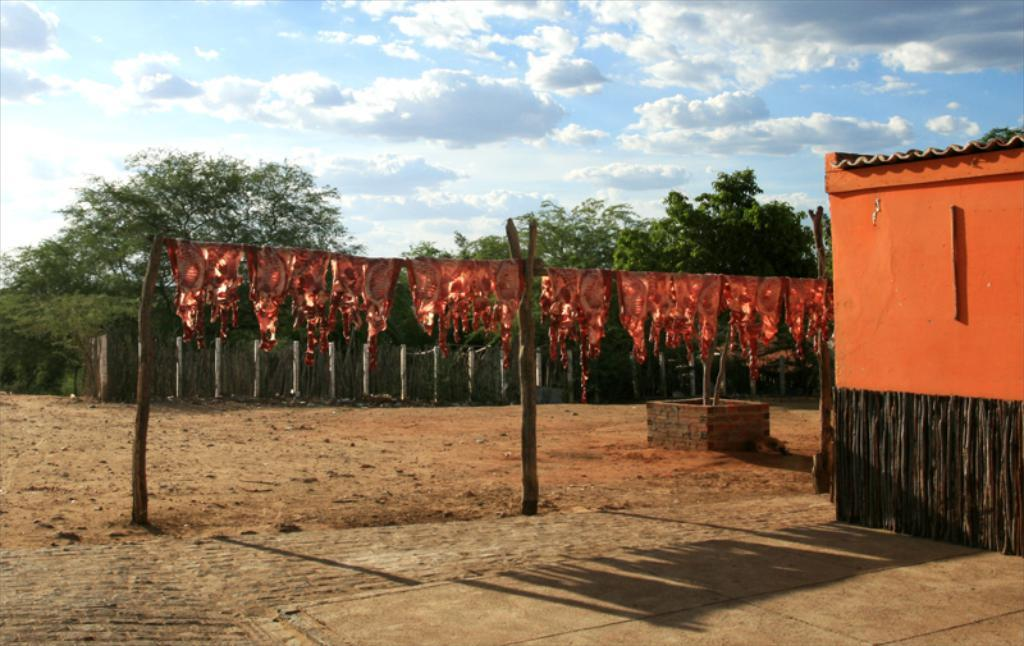What is visible in the center of the image? The sky is visible in the center of the image. What can be seen in the sky? Clouds are present in the image. What type of vegetation is in the image? Trees are in the image. What type of structure is in the image? There is a house in the image. What type of barrier is in the image? There is a fence in the image. What type of vertical structures are in the image? Poles are present in the image. What type of food is visible in the image? Meat on sticks is visible in the image. Are there any other objects in the image? Yes, there are a few other objects in the image. What type of paste is being used in the image? There is no mention of paste in the image. 